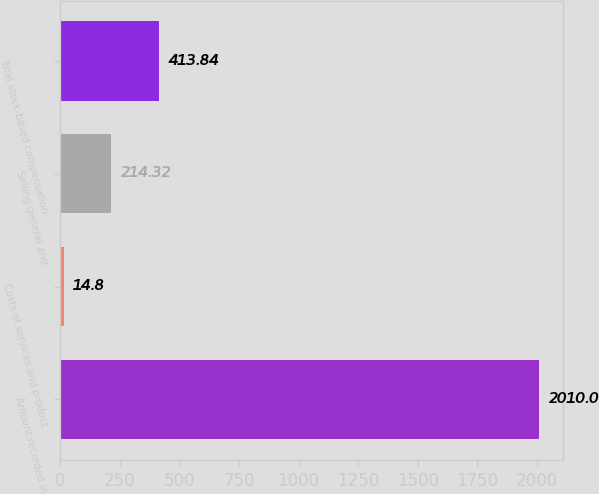Convert chart to OTSL. <chart><loc_0><loc_0><loc_500><loc_500><bar_chart><fcel>Amount recorded in<fcel>Costs of services and product<fcel>Selling general and<fcel>Total stock-based compensation<nl><fcel>2010<fcel>14.8<fcel>214.32<fcel>413.84<nl></chart> 